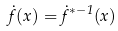Convert formula to latex. <formula><loc_0><loc_0><loc_500><loc_500>\dot { f } ( x ) = \dot { f } ^ { * - 1 } ( x )</formula> 